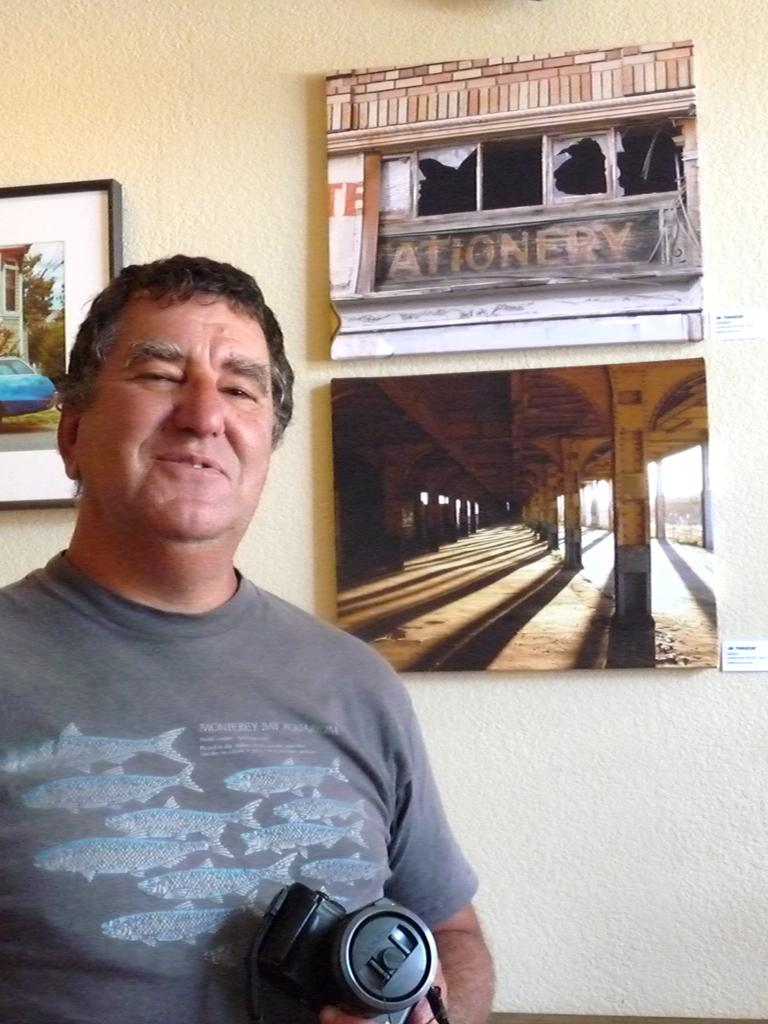What is the man in the image doing? The man is holding a camera in his hand. What is the man's facial expression in the image? The man is smiling. What can be seen in the background of the image? There is a wall with frames and photos in the background of the image. What type of gun is the man holding in the image? There is no gun present in the image; the man is holding a camera. What sound does the bell make in the image? There is no bell present in the image. 